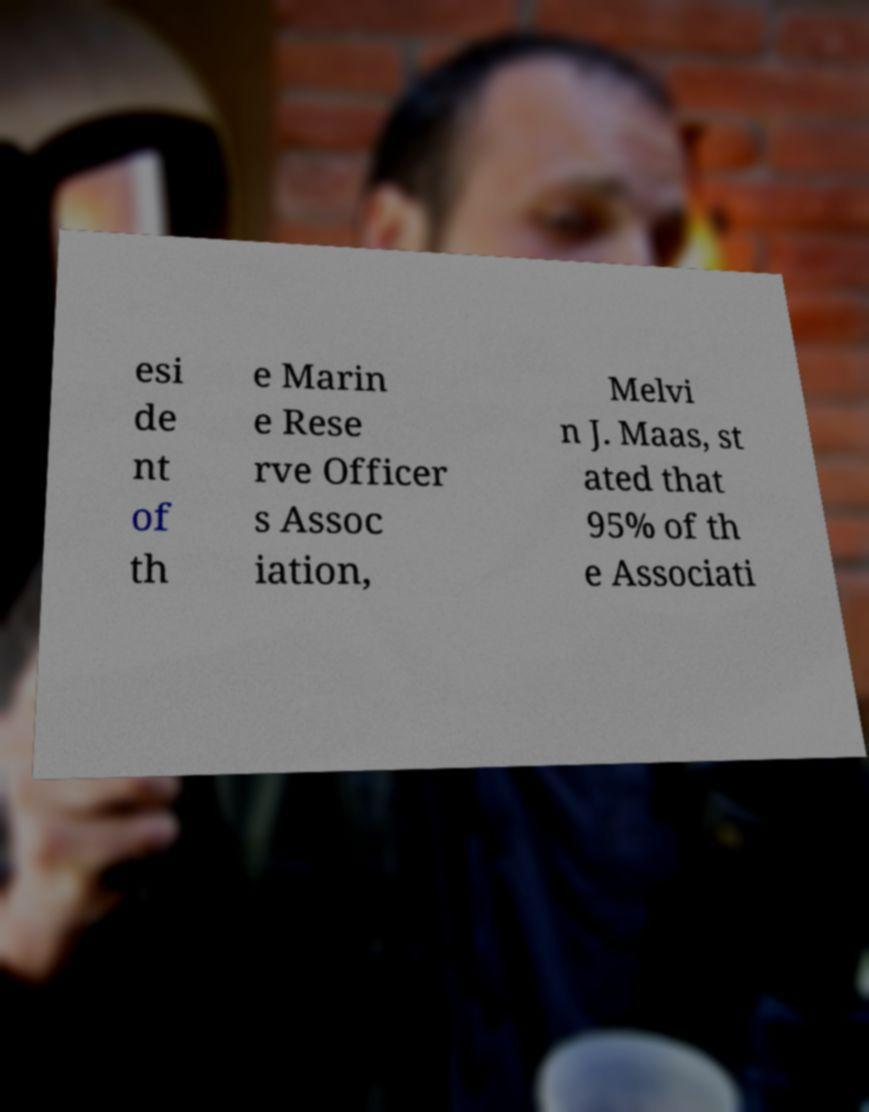Can you read and provide the text displayed in the image?This photo seems to have some interesting text. Can you extract and type it out for me? esi de nt of th e Marin e Rese rve Officer s Assoc iation, Melvi n J. Maas, st ated that 95% of th e Associati 